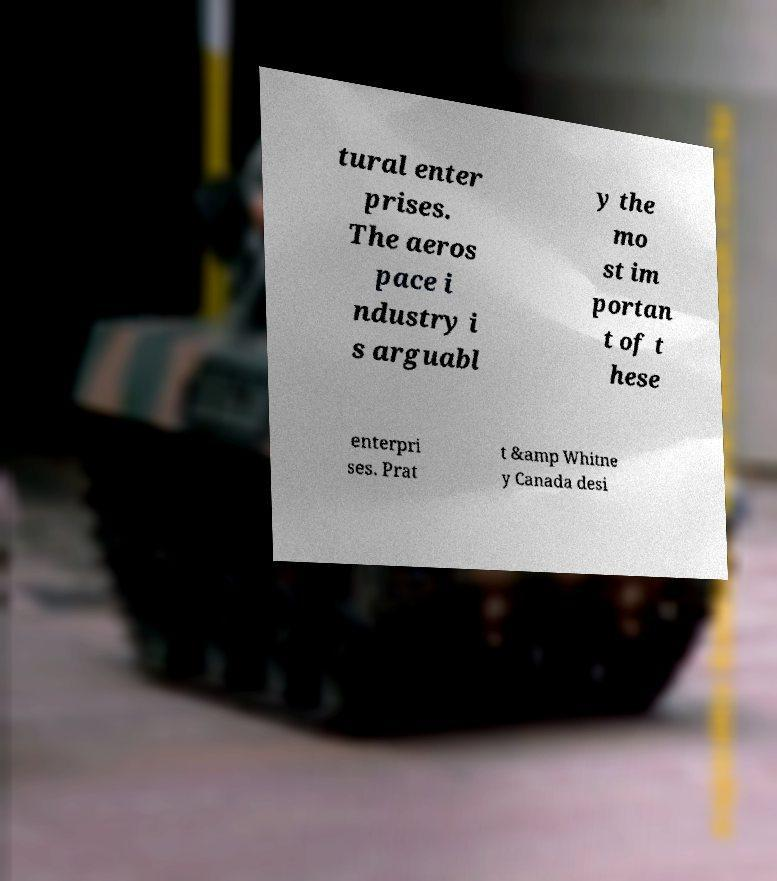Please read and relay the text visible in this image. What does it say? tural enter prises. The aeros pace i ndustry i s arguabl y the mo st im portan t of t hese enterpri ses. Prat t &amp Whitne y Canada desi 